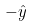<formula> <loc_0><loc_0><loc_500><loc_500>- \hat { y }</formula> 